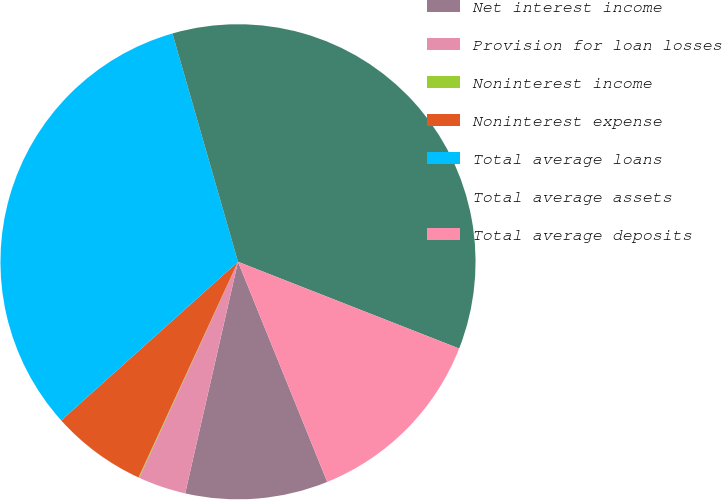<chart> <loc_0><loc_0><loc_500><loc_500><pie_chart><fcel>Net interest income<fcel>Provision for loan losses<fcel>Noninterest income<fcel>Noninterest expense<fcel>Total average loans<fcel>Total average assets<fcel>Total average deposits<nl><fcel>9.7%<fcel>3.26%<fcel>0.05%<fcel>6.48%<fcel>32.19%<fcel>35.4%<fcel>12.92%<nl></chart> 